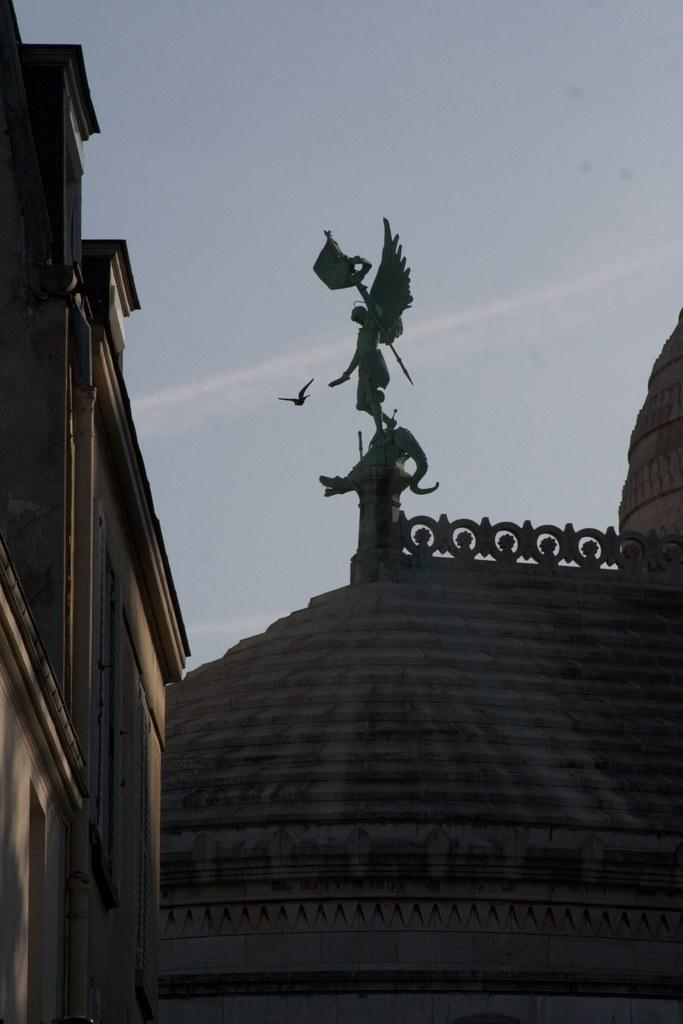What is the main subject in the middle of the image? There is a statue in the middle of the image. What structure can be seen on the left side of the image? There is a building on the left side of the image. What is visible at the top of the image? The sky is visible at the top of the image. Can you describe any activity happening in the sky? A bird is flying in the sky. What type of yam is being held by the statue in the image? There is no yam present in the image, and the statue is not holding anything. 